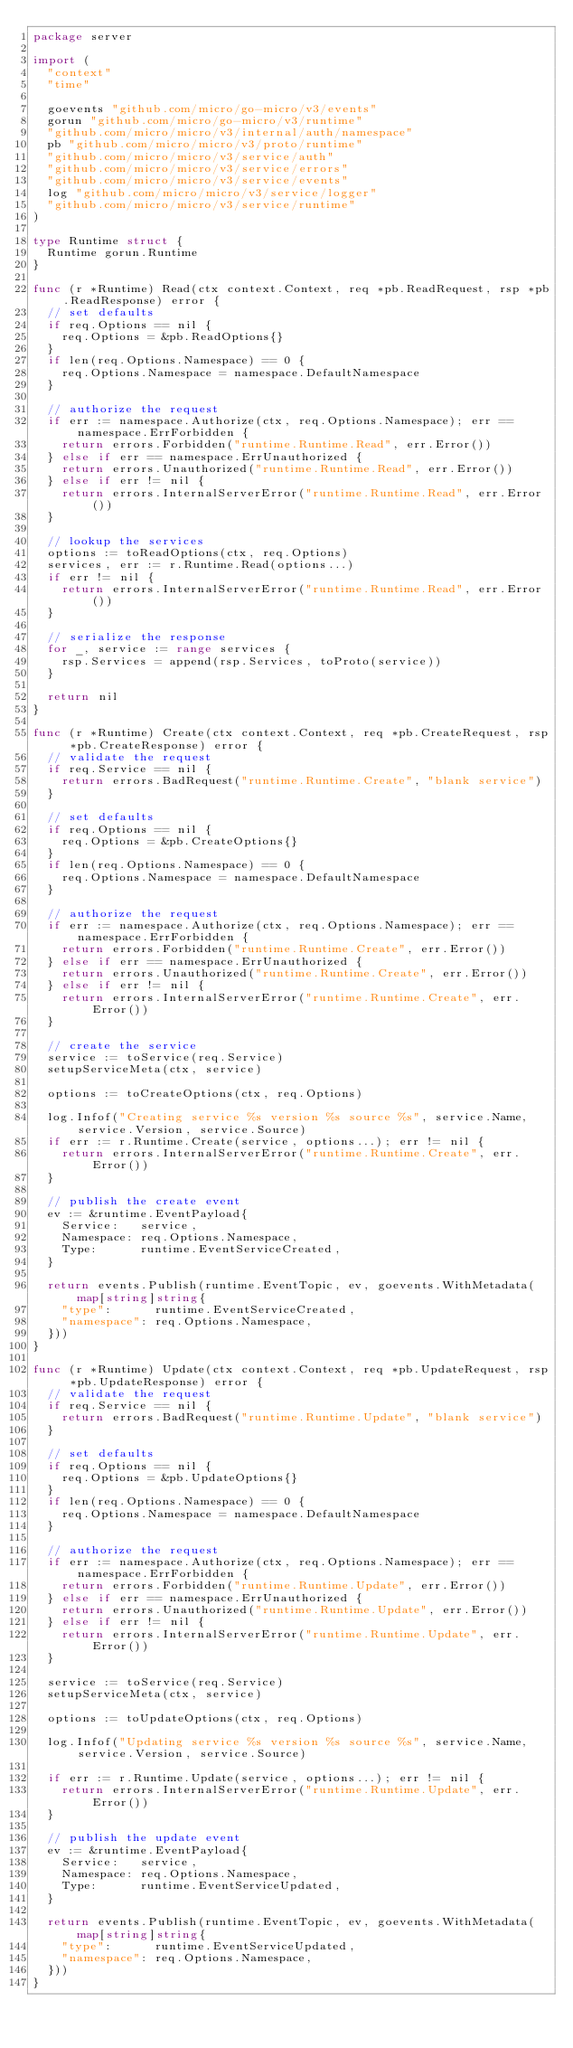<code> <loc_0><loc_0><loc_500><loc_500><_Go_>package server

import (
	"context"
	"time"

	goevents "github.com/micro/go-micro/v3/events"
	gorun "github.com/micro/go-micro/v3/runtime"
	"github.com/micro/micro/v3/internal/auth/namespace"
	pb "github.com/micro/micro/v3/proto/runtime"
	"github.com/micro/micro/v3/service/auth"
	"github.com/micro/micro/v3/service/errors"
	"github.com/micro/micro/v3/service/events"
	log "github.com/micro/micro/v3/service/logger"
	"github.com/micro/micro/v3/service/runtime"
)

type Runtime struct {
	Runtime gorun.Runtime
}

func (r *Runtime) Read(ctx context.Context, req *pb.ReadRequest, rsp *pb.ReadResponse) error {
	// set defaults
	if req.Options == nil {
		req.Options = &pb.ReadOptions{}
	}
	if len(req.Options.Namespace) == 0 {
		req.Options.Namespace = namespace.DefaultNamespace
	}

	// authorize the request
	if err := namespace.Authorize(ctx, req.Options.Namespace); err == namespace.ErrForbidden {
		return errors.Forbidden("runtime.Runtime.Read", err.Error())
	} else if err == namespace.ErrUnauthorized {
		return errors.Unauthorized("runtime.Runtime.Read", err.Error())
	} else if err != nil {
		return errors.InternalServerError("runtime.Runtime.Read", err.Error())
	}

	// lookup the services
	options := toReadOptions(ctx, req.Options)
	services, err := r.Runtime.Read(options...)
	if err != nil {
		return errors.InternalServerError("runtime.Runtime.Read", err.Error())
	}

	// serialize the response
	for _, service := range services {
		rsp.Services = append(rsp.Services, toProto(service))
	}

	return nil
}

func (r *Runtime) Create(ctx context.Context, req *pb.CreateRequest, rsp *pb.CreateResponse) error {
	// validate the request
	if req.Service == nil {
		return errors.BadRequest("runtime.Runtime.Create", "blank service")
	}

	// set defaults
	if req.Options == nil {
		req.Options = &pb.CreateOptions{}
	}
	if len(req.Options.Namespace) == 0 {
		req.Options.Namespace = namespace.DefaultNamespace
	}

	// authorize the request
	if err := namespace.Authorize(ctx, req.Options.Namespace); err == namespace.ErrForbidden {
		return errors.Forbidden("runtime.Runtime.Create", err.Error())
	} else if err == namespace.ErrUnauthorized {
		return errors.Unauthorized("runtime.Runtime.Create", err.Error())
	} else if err != nil {
		return errors.InternalServerError("runtime.Runtime.Create", err.Error())
	}

	// create the service
	service := toService(req.Service)
	setupServiceMeta(ctx, service)

	options := toCreateOptions(ctx, req.Options)

	log.Infof("Creating service %s version %s source %s", service.Name, service.Version, service.Source)
	if err := r.Runtime.Create(service, options...); err != nil {
		return errors.InternalServerError("runtime.Runtime.Create", err.Error())
	}

	// publish the create event
	ev := &runtime.EventPayload{
		Service:   service,
		Namespace: req.Options.Namespace,
		Type:      runtime.EventServiceCreated,
	}

	return events.Publish(runtime.EventTopic, ev, goevents.WithMetadata(map[string]string{
		"type":      runtime.EventServiceCreated,
		"namespace": req.Options.Namespace,
	}))
}

func (r *Runtime) Update(ctx context.Context, req *pb.UpdateRequest, rsp *pb.UpdateResponse) error {
	// validate the request
	if req.Service == nil {
		return errors.BadRequest("runtime.Runtime.Update", "blank service")
	}

	// set defaults
	if req.Options == nil {
		req.Options = &pb.UpdateOptions{}
	}
	if len(req.Options.Namespace) == 0 {
		req.Options.Namespace = namespace.DefaultNamespace
	}

	// authorize the request
	if err := namespace.Authorize(ctx, req.Options.Namespace); err == namespace.ErrForbidden {
		return errors.Forbidden("runtime.Runtime.Update", err.Error())
	} else if err == namespace.ErrUnauthorized {
		return errors.Unauthorized("runtime.Runtime.Update", err.Error())
	} else if err != nil {
		return errors.InternalServerError("runtime.Runtime.Update", err.Error())
	}

	service := toService(req.Service)
	setupServiceMeta(ctx, service)

	options := toUpdateOptions(ctx, req.Options)

	log.Infof("Updating service %s version %s source %s", service.Name, service.Version, service.Source)

	if err := r.Runtime.Update(service, options...); err != nil {
		return errors.InternalServerError("runtime.Runtime.Update", err.Error())
	}

	// publish the update event
	ev := &runtime.EventPayload{
		Service:   service,
		Namespace: req.Options.Namespace,
		Type:      runtime.EventServiceUpdated,
	}

	return events.Publish(runtime.EventTopic, ev, goevents.WithMetadata(map[string]string{
		"type":      runtime.EventServiceUpdated,
		"namespace": req.Options.Namespace,
	}))
}
</code> 